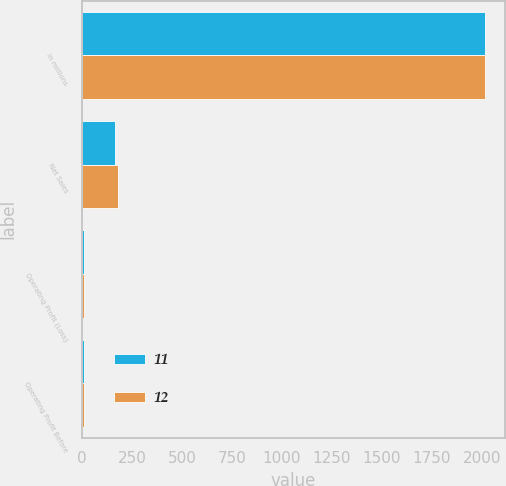<chart> <loc_0><loc_0><loc_500><loc_500><stacked_bar_chart><ecel><fcel>In millions<fcel>Net Sales<fcel>Operating Profit (Loss)<fcel>Operating Profit Before<nl><fcel>11<fcel>2016<fcel>167<fcel>11<fcel>11<nl><fcel>12<fcel>2014<fcel>178<fcel>8<fcel>12<nl></chart> 